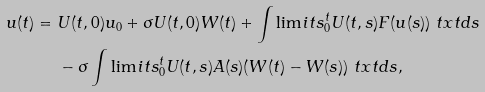Convert formula to latex. <formula><loc_0><loc_0><loc_500><loc_500>u ( t ) = & \ U ( t , 0 ) u _ { 0 } + \sigma U ( t , 0 ) W ( t ) + \int \lim i t s _ { 0 } ^ { t } U ( t , s ) F ( u ( s ) ) \ t x t d s \\ & \ - \sigma \int \lim i t s _ { 0 } ^ { t } U ( t , s ) A ( s ) ( W ( t ) - W ( s ) ) \ t x t d s ,</formula> 